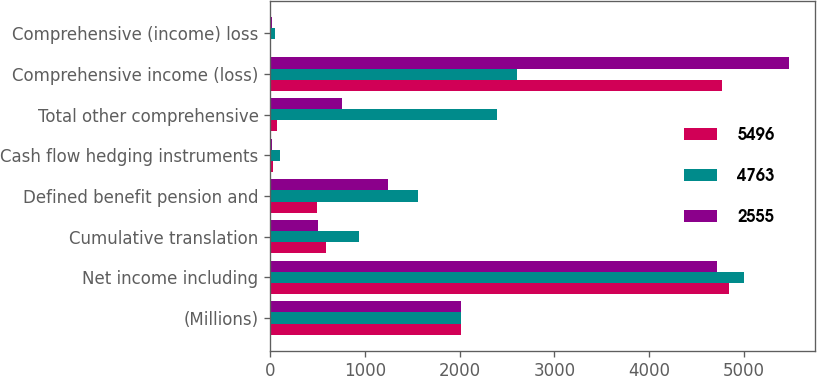Convert chart. <chart><loc_0><loc_0><loc_500><loc_500><stacked_bar_chart><ecel><fcel>(Millions)<fcel>Net income including<fcel>Cumulative translation<fcel>Defined benefit pension and<fcel>Cash flow hedging instruments<fcel>Total other comprehensive<fcel>Comprehensive income (loss)<fcel>Comprehensive (income) loss<nl><fcel>5496<fcel>2015<fcel>4841<fcel>586<fcel>489<fcel>25<fcel>72<fcel>4769<fcel>6<nl><fcel>4763<fcel>2014<fcel>4998<fcel>942<fcel>1562<fcel>107<fcel>2395<fcel>2603<fcel>48<nl><fcel>2555<fcel>2013<fcel>4721<fcel>505<fcel>1245<fcel>15<fcel>755<fcel>5476<fcel>20<nl></chart> 